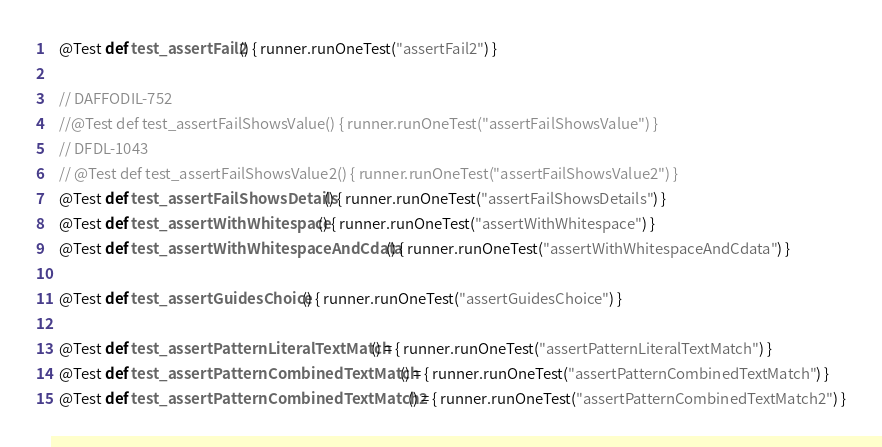Convert code to text. <code><loc_0><loc_0><loc_500><loc_500><_Scala_>  @Test def test_assertFail2() { runner.runOneTest("assertFail2") }

  // DAFFODIL-752
  //@Test def test_assertFailShowsValue() { runner.runOneTest("assertFailShowsValue") }
  // DFDL-1043
  // @Test def test_assertFailShowsValue2() { runner.runOneTest("assertFailShowsValue2") }
  @Test def test_assertFailShowsDetails() { runner.runOneTest("assertFailShowsDetails") }
  @Test def test_assertWithWhitespace() { runner.runOneTest("assertWithWhitespace") }
  @Test def test_assertWithWhitespaceAndCdata() { runner.runOneTest("assertWithWhitespaceAndCdata") }

  @Test def test_assertGuidesChoice() { runner.runOneTest("assertGuidesChoice") }

  @Test def test_assertPatternLiteralTextMatch() = { runner.runOneTest("assertPatternLiteralTextMatch") }
  @Test def test_assertPatternCombinedTextMatch() = { runner.runOneTest("assertPatternCombinedTextMatch") }
  @Test def test_assertPatternCombinedTextMatch2() = { runner.runOneTest("assertPatternCombinedTextMatch2") }</code> 